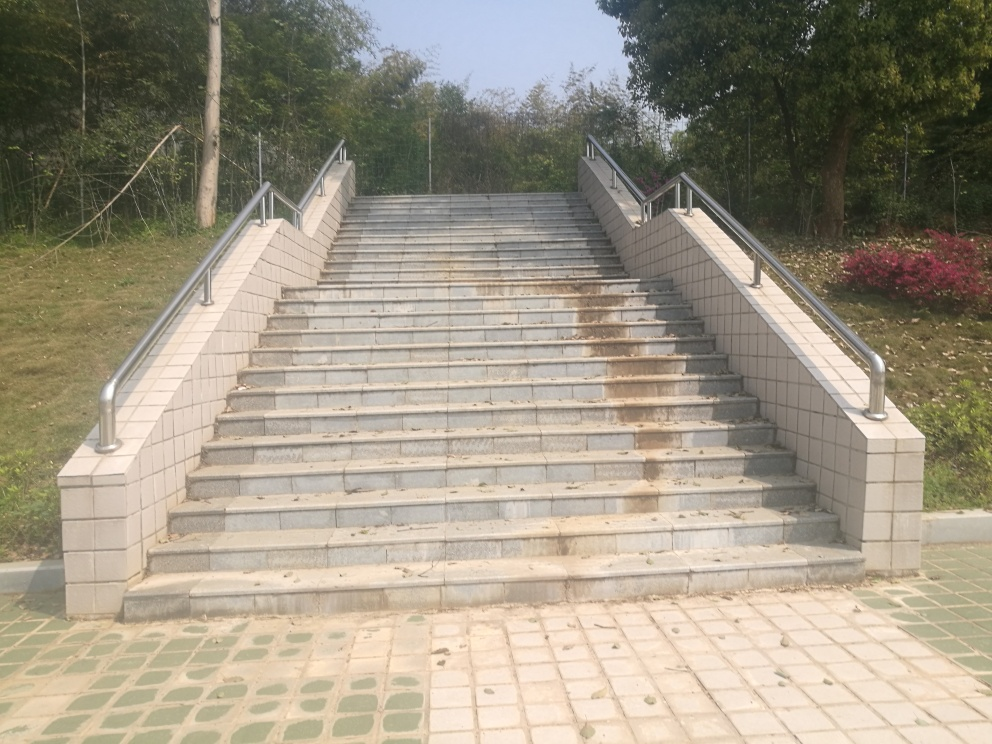What kind of maintenance does the staircase appear to require? The staircase shows signs of wear and some staining, indicating that regular cleaning could restore its appearance. Additionally, several of the steps show darker markings, which might suggest the need for pressure washing or a similar deep-cleaning process. 